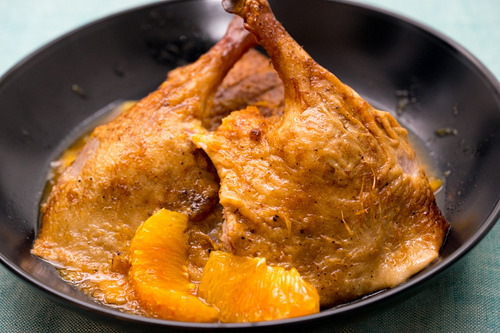<image>
Is the orange to the left of the chicken? No. The orange is not to the left of the chicken. From this viewpoint, they have a different horizontal relationship. 